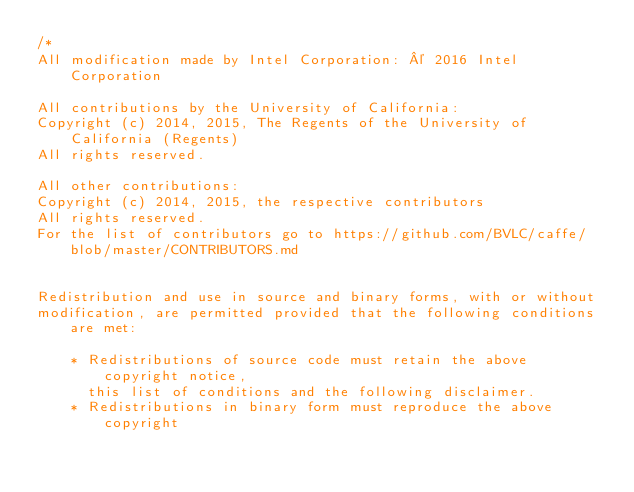Convert code to text. <code><loc_0><loc_0><loc_500><loc_500><_Cuda_>/*
All modification made by Intel Corporation: © 2016 Intel Corporation

All contributions by the University of California:
Copyright (c) 2014, 2015, The Regents of the University of California (Regents)
All rights reserved.

All other contributions:
Copyright (c) 2014, 2015, the respective contributors
All rights reserved.
For the list of contributors go to https://github.com/BVLC/caffe/blob/master/CONTRIBUTORS.md


Redistribution and use in source and binary forms, with or without
modification, are permitted provided that the following conditions are met:

    * Redistributions of source code must retain the above copyright notice,
      this list of conditions and the following disclaimer.
    * Redistributions in binary form must reproduce the above copyright</code> 